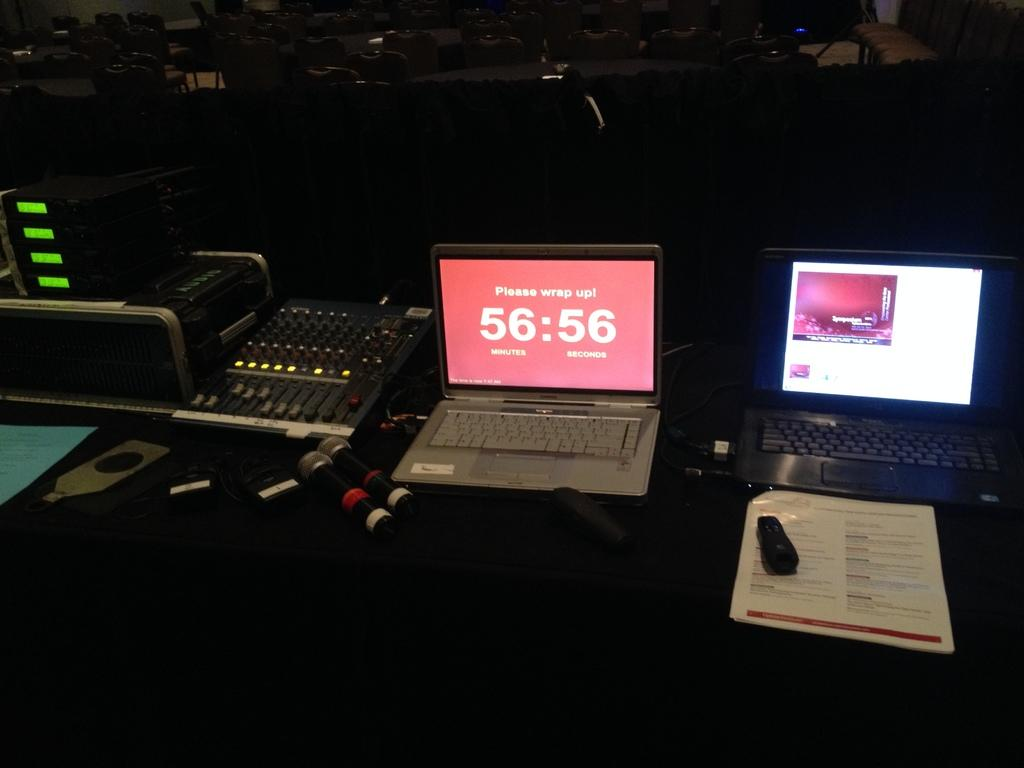<image>
Write a terse but informative summary of the picture. A laptop with a screen message indicating a timer of 56 minutes and 56 seconds. 